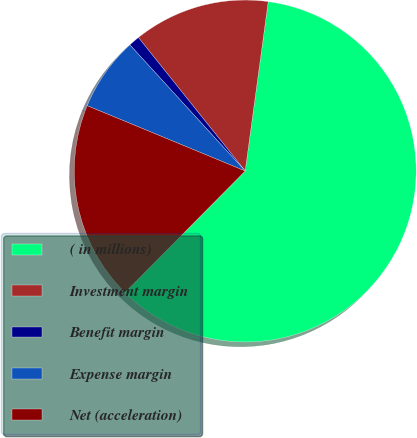<chart> <loc_0><loc_0><loc_500><loc_500><pie_chart><fcel>( in millions)<fcel>Investment margin<fcel>Benefit margin<fcel>Expense margin<fcel>Net (acceleration)<nl><fcel>60.27%<fcel>12.89%<fcel>1.05%<fcel>6.97%<fcel>18.82%<nl></chart> 